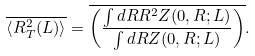<formula> <loc_0><loc_0><loc_500><loc_500>\overline { { \langle } { R } _ { T } ^ { 2 } ( L ) { \rangle } } = \overline { \left ( \frac { \int d { R } { R } ^ { 2 } Z ( { 0 } , { R } ; L ) } { \int d { R } Z ( { 0 } , { R } ; L ) } \right ) } .</formula> 